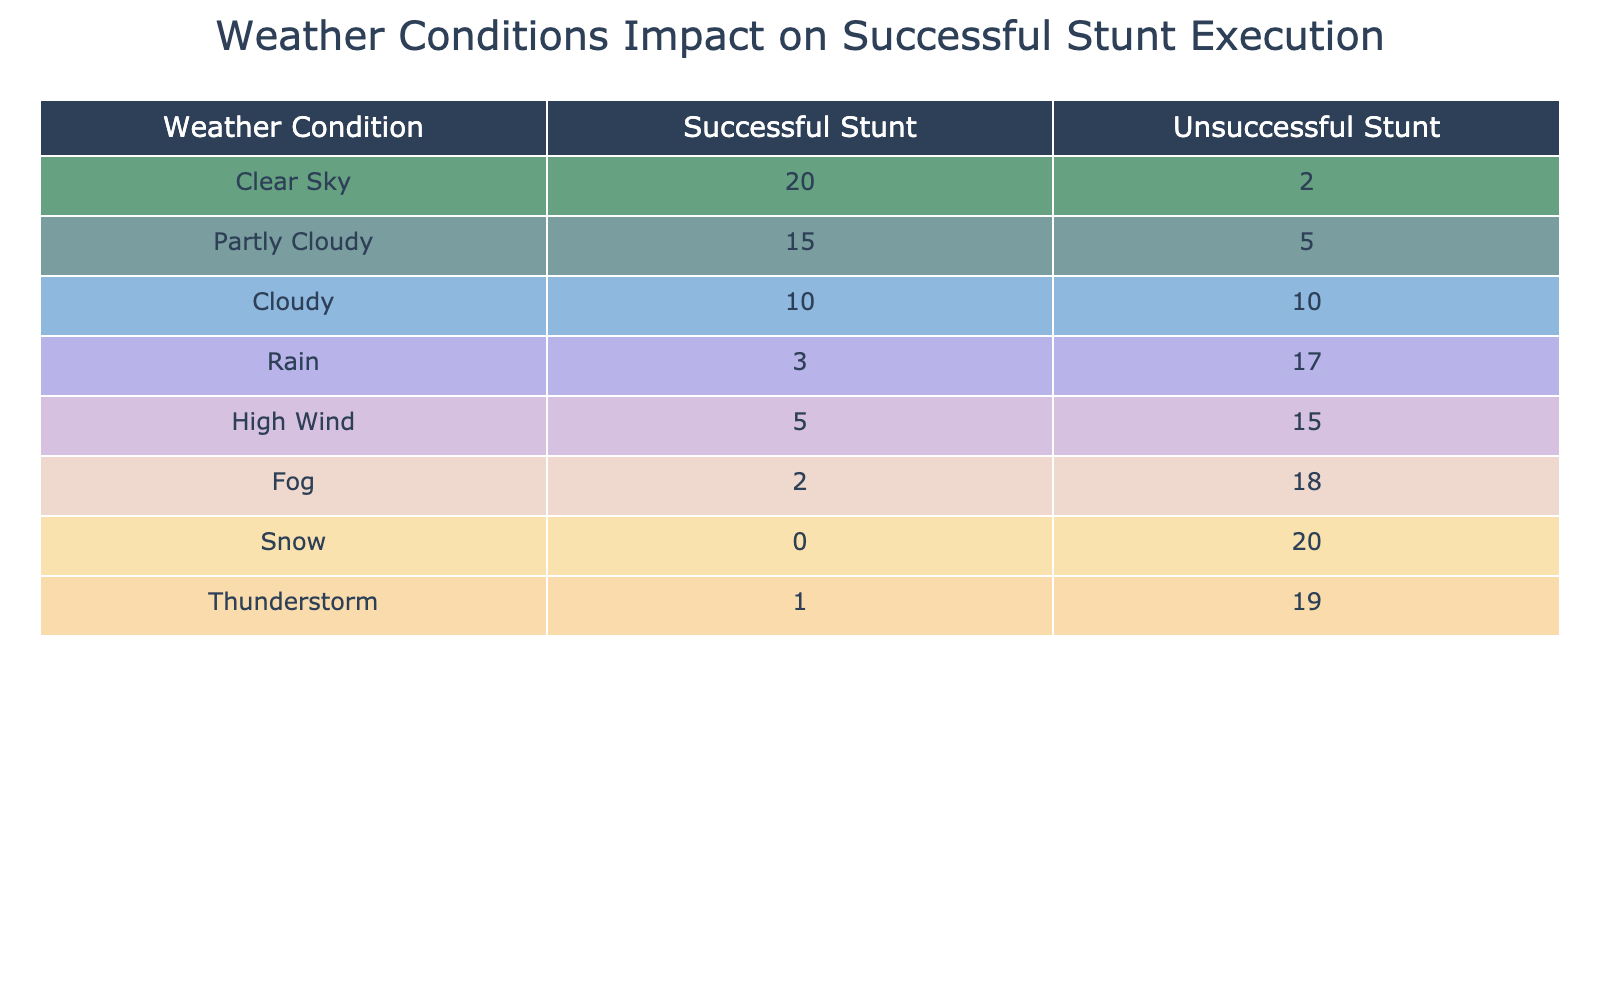What is the total number of successful stunts performed under clear sky conditions? The table shows that under clear sky conditions, 20 successful stunts were performed.
Answer: 20 What weather condition had the highest number of unsuccessful stunts? The table indicates that "Snow" had the highest number of unsuccessful stunts, which is 20.
Answer: Snow How many successful stunts were performed in windy conditions compared to rain? For windy conditions (High Wind), 5 successful stunts were performed, and under rain, 3 successful stunts were noted. Comparing these, windy conditions had 2 more successful stunts than rain conditions (5 - 3 = 2).
Answer: 2 What is the average number of successful stunts across all weather conditions? Adding the successful stunts: 20 (Clear) + 15 (Partly Cloudy) + 10 (Cloudy) + 3 (Rain) + 5 (High Wind) + 2 (Fog) + 0 (Snow) + 1 (Thunderstorm) = 56. There are 8 weather conditions, so the average is 56/8 = 7.
Answer: 7 Is it true that more successful stunts were performed under partly cloudy conditions than under thunderstorms? Under partly cloudy conditions, 15 successful stunts were performed, while under thunderstorms, only 1 successful stunt was noted. Therefore, it is true that more successful stunts were performed in partly cloudy conditions than under thunderstorms.
Answer: Yes What is the total count of unsuccessful stunts if we combine fog and snow conditions? The table shows that there were 18 unsuccessful stunts under fog and 20 under snow. Adding these together gives 18 + 20 = 38 unsuccessful stunts in total under those two conditions.
Answer: 38 Which weather condition had the least impact on successful stunt execution, and how many successful stunts were recorded? The least impact on successful stunt execution was under "Snow," with 0 successful stunts recorded.
Answer: Snow, 0 How many weather conditions had more than 10 successful stunts? The weather conditions that had more than 10 successful stunts are clear sky (20), partly cloudy (15), and cloudy (10). However, only clear and partly cloudy exceed 10. Therefore, there are 2 such conditions.
Answer: 2 What is the difference in the number of successful stunts between cloudy and rainy conditions? The table shows 10 successful stunts were performed in cloudy conditions and 3 in rainy conditions. The difference is 10 - 3 = 7 successful stunts, indicating that cloudy conditions had 7 more successful stunts than rainy conditions.
Answer: 7 